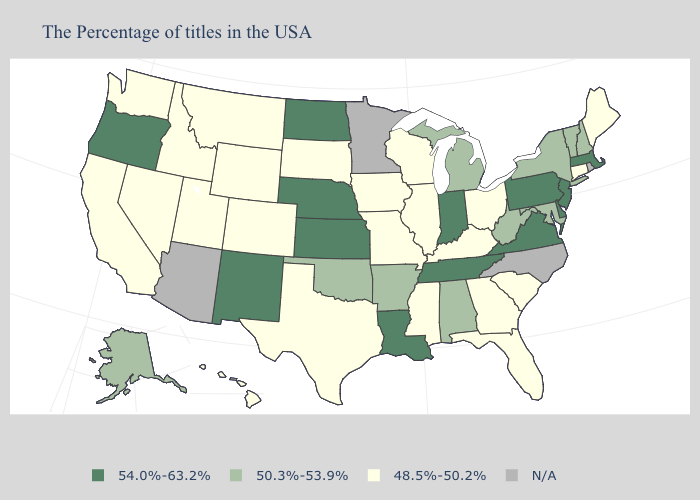Name the states that have a value in the range 50.3%-53.9%?
Short answer required. New Hampshire, Vermont, New York, Maryland, West Virginia, Michigan, Alabama, Arkansas, Oklahoma, Alaska. Name the states that have a value in the range N/A?
Keep it brief. Rhode Island, North Carolina, Minnesota, Arizona. Among the states that border Illinois , does Indiana have the highest value?
Answer briefly. Yes. What is the highest value in states that border Georgia?
Give a very brief answer. 54.0%-63.2%. Name the states that have a value in the range 50.3%-53.9%?
Keep it brief. New Hampshire, Vermont, New York, Maryland, West Virginia, Michigan, Alabama, Arkansas, Oklahoma, Alaska. What is the value of Tennessee?
Concise answer only. 54.0%-63.2%. Name the states that have a value in the range N/A?
Be succinct. Rhode Island, North Carolina, Minnesota, Arizona. What is the value of Arizona?
Keep it brief. N/A. What is the value of California?
Be succinct. 48.5%-50.2%. What is the value of Mississippi?
Answer briefly. 48.5%-50.2%. Name the states that have a value in the range N/A?
Short answer required. Rhode Island, North Carolina, Minnesota, Arizona. Does Kansas have the highest value in the MidWest?
Short answer required. Yes. What is the value of Hawaii?
Give a very brief answer. 48.5%-50.2%. What is the value of Ohio?
Give a very brief answer. 48.5%-50.2%. 